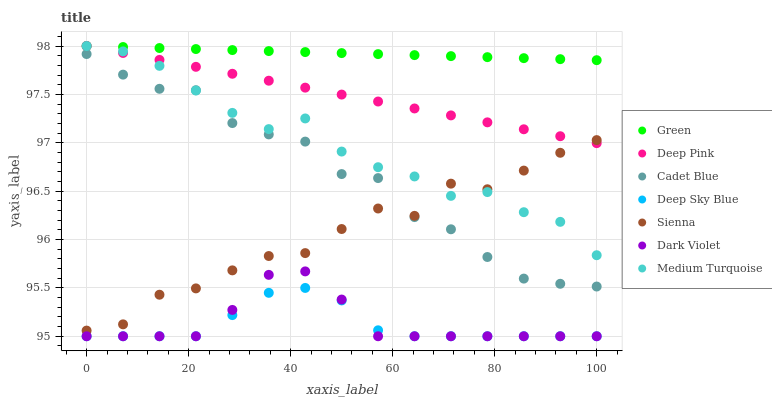Does Deep Sky Blue have the minimum area under the curve?
Answer yes or no. Yes. Does Green have the maximum area under the curve?
Answer yes or no. Yes. Does Medium Turquoise have the minimum area under the curve?
Answer yes or no. No. Does Medium Turquoise have the maximum area under the curve?
Answer yes or no. No. Is Green the smoothest?
Answer yes or no. Yes. Is Sienna the roughest?
Answer yes or no. Yes. Is Medium Turquoise the smoothest?
Answer yes or no. No. Is Medium Turquoise the roughest?
Answer yes or no. No. Does Dark Violet have the lowest value?
Answer yes or no. Yes. Does Medium Turquoise have the lowest value?
Answer yes or no. No. Does Green have the highest value?
Answer yes or no. Yes. Does Dark Violet have the highest value?
Answer yes or no. No. Is Dark Violet less than Green?
Answer yes or no. Yes. Is Cadet Blue greater than Deep Sky Blue?
Answer yes or no. Yes. Does Cadet Blue intersect Medium Turquoise?
Answer yes or no. Yes. Is Cadet Blue less than Medium Turquoise?
Answer yes or no. No. Is Cadet Blue greater than Medium Turquoise?
Answer yes or no. No. Does Dark Violet intersect Green?
Answer yes or no. No. 